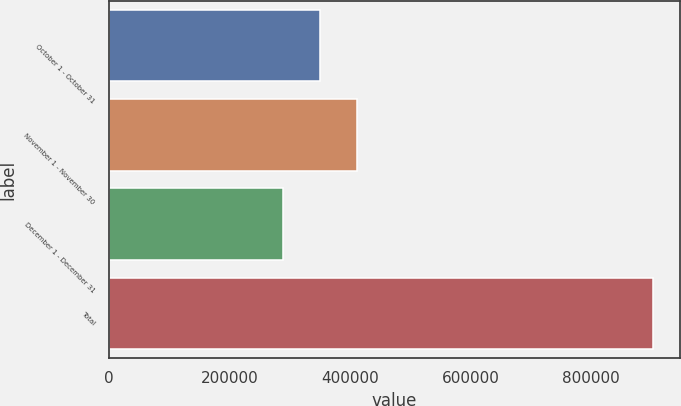Convert chart. <chart><loc_0><loc_0><loc_500><loc_500><bar_chart><fcel>October 1 - October 31<fcel>November 1 - November 30<fcel>December 1 - December 31<fcel>Total<nl><fcel>350040<fcel>411471<fcel>288609<fcel>902920<nl></chart> 